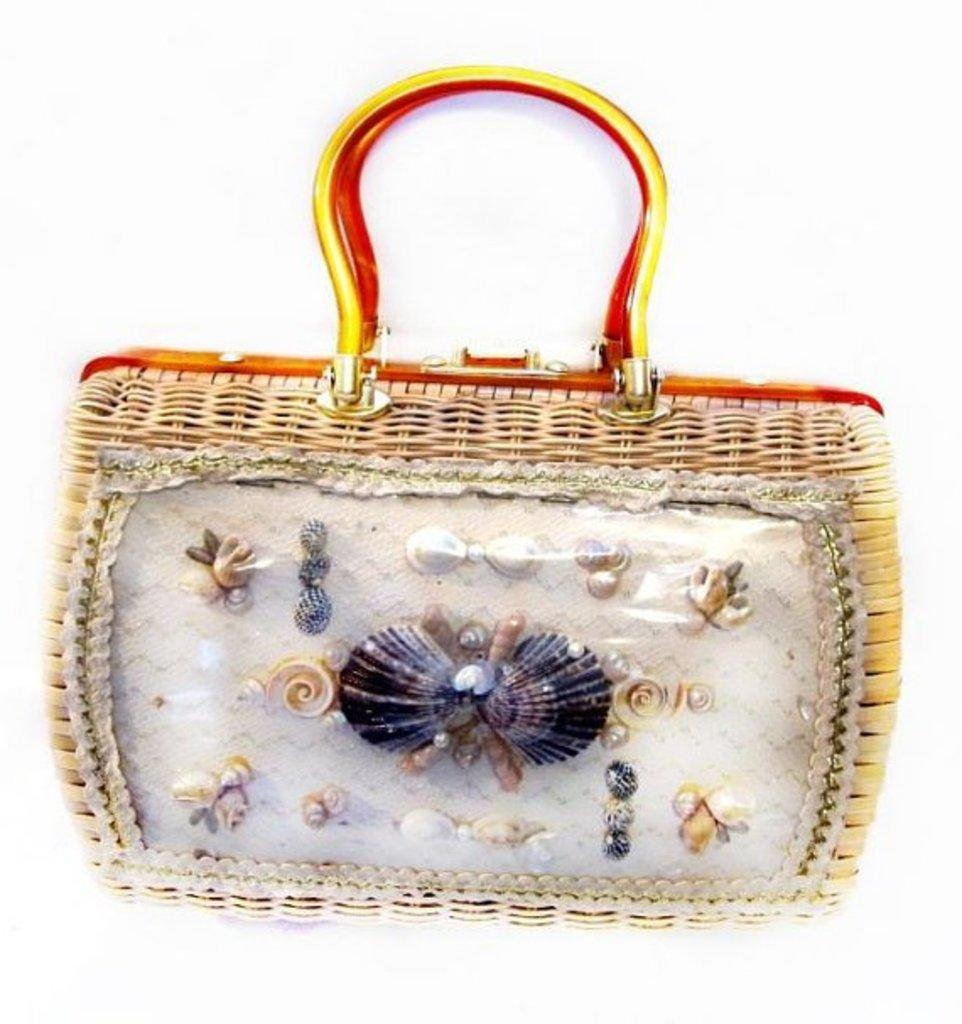What object can be seen in the image? There is a purse in the image. What material is the purse made of? The purse is made up of jute. What items are inside the purse? The purse contains shells and marbles. What colors are visible on the purse? The purse is yellow and red in color. What is the acoustics of the purse like in the image? The image does not provide information about the acoustics of the purse, as it is a visual representation. 